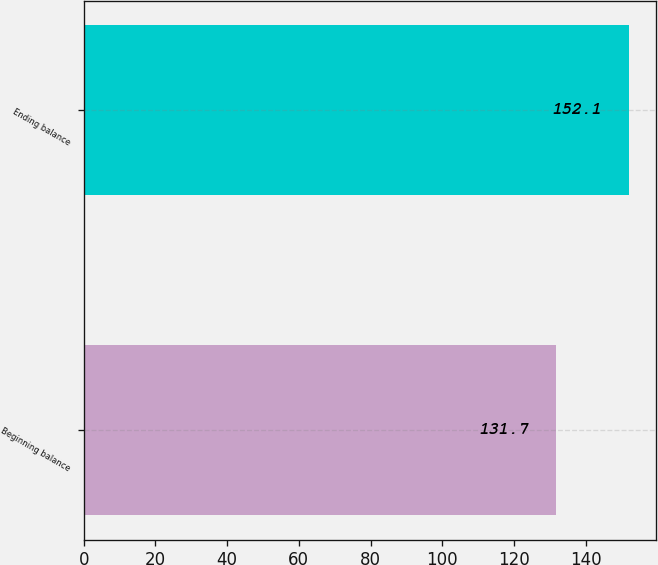Convert chart. <chart><loc_0><loc_0><loc_500><loc_500><bar_chart><fcel>Beginning balance<fcel>Ending balance<nl><fcel>131.7<fcel>152.1<nl></chart> 